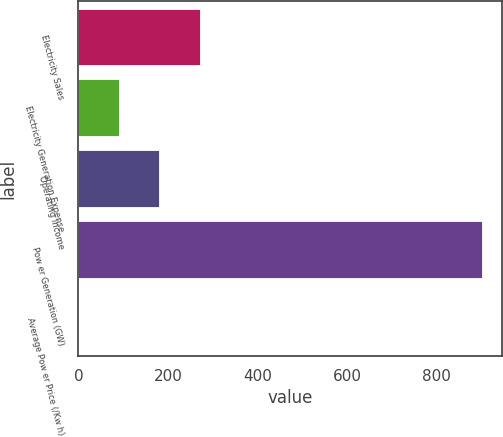Convert chart. <chart><loc_0><loc_0><loc_500><loc_500><bar_chart><fcel>Electricity Sales<fcel>Electricity Generation Expense<fcel>Operating Income<fcel>Pow er Generation (GW)<fcel>Average Pow er Price (/Kw h)<nl><fcel>270.65<fcel>90.27<fcel>180.46<fcel>902<fcel>0.08<nl></chart> 